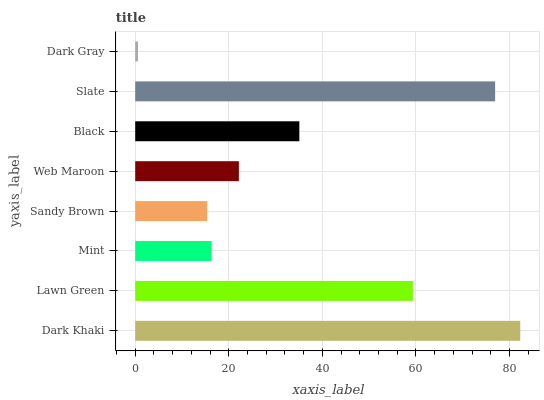Is Dark Gray the minimum?
Answer yes or no. Yes. Is Dark Khaki the maximum?
Answer yes or no. Yes. Is Lawn Green the minimum?
Answer yes or no. No. Is Lawn Green the maximum?
Answer yes or no. No. Is Dark Khaki greater than Lawn Green?
Answer yes or no. Yes. Is Lawn Green less than Dark Khaki?
Answer yes or no. Yes. Is Lawn Green greater than Dark Khaki?
Answer yes or no. No. Is Dark Khaki less than Lawn Green?
Answer yes or no. No. Is Black the high median?
Answer yes or no. Yes. Is Web Maroon the low median?
Answer yes or no. Yes. Is Dark Khaki the high median?
Answer yes or no. No. Is Slate the low median?
Answer yes or no. No. 